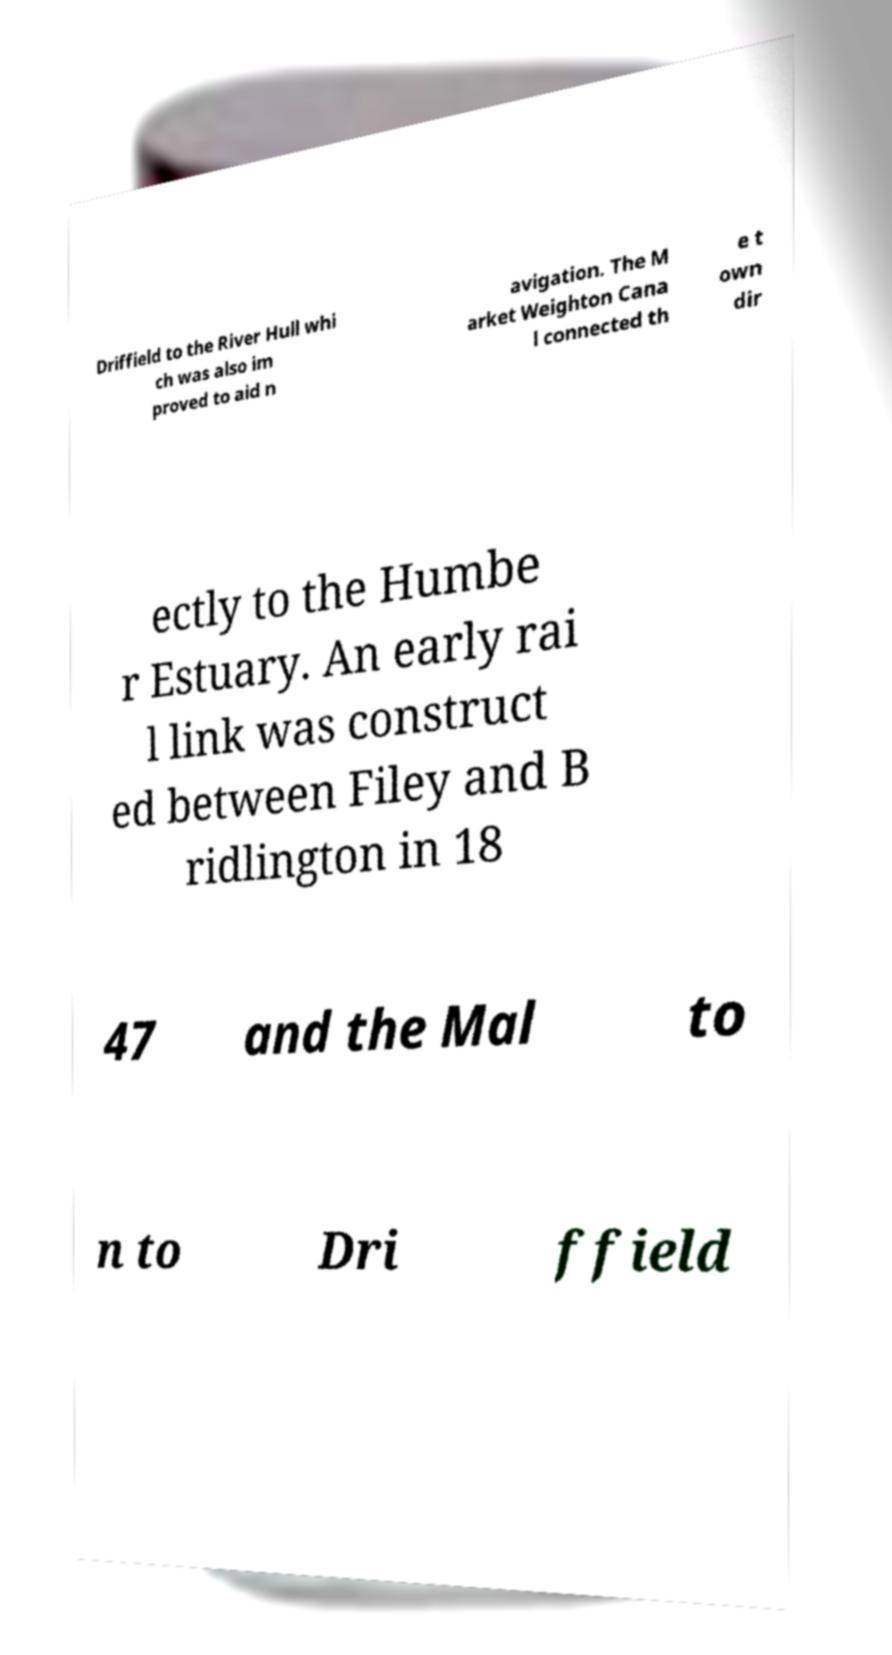Could you extract and type out the text from this image? Driffield to the River Hull whi ch was also im proved to aid n avigation. The M arket Weighton Cana l connected th e t own dir ectly to the Humbe r Estuary. An early rai l link was construct ed between Filey and B ridlington in 18 47 and the Mal to n to Dri ffield 